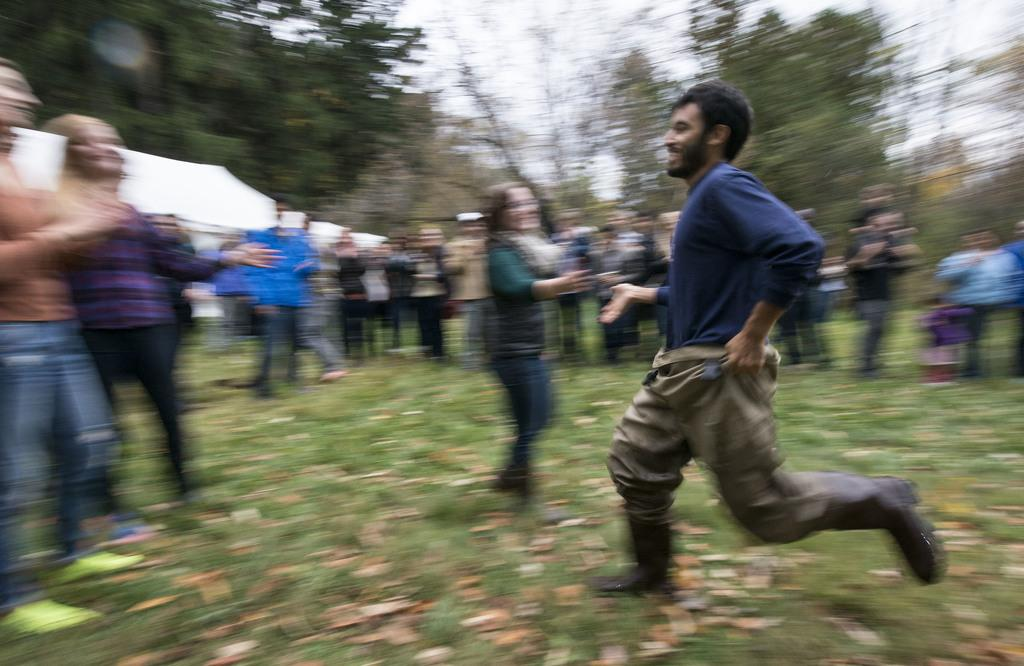Who or what can be seen in the image? There are people in the image. What type of natural environment is visible in the image? There is grass visible in the image, as well as trees. What can be found on the ground in the image? Leaves are present in the image. What is visible in the background of the image? The sky is visible in the background of the image. How many feet are being used to smash the leaves in the image? There are no feet or smashing of leaves depicted in the image. Is there a bath visible in the image? There is no bath present in the image. 